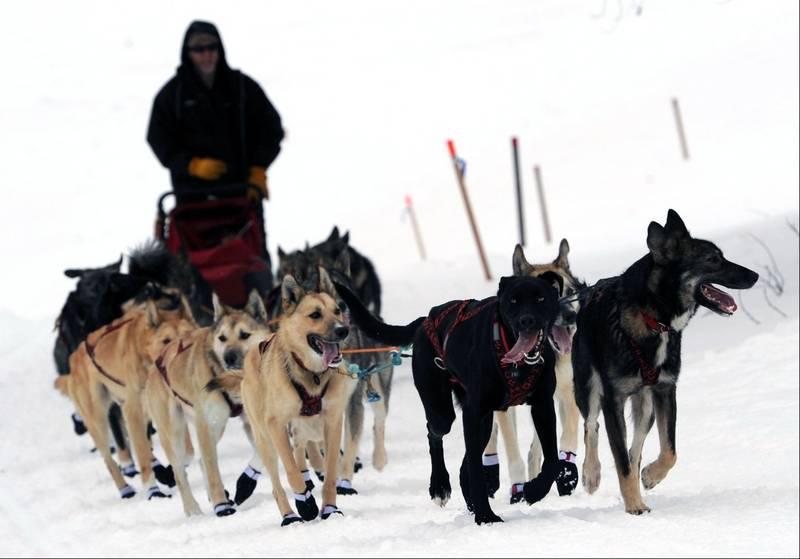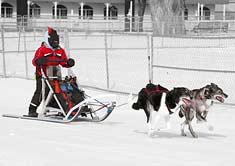The first image is the image on the left, the second image is the image on the right. Given the left and right images, does the statement "Most of the dogs on one sled team are wearing black booties with a white band across the top." hold true? Answer yes or no. Yes. The first image is the image on the left, the second image is the image on the right. Evaluate the accuracy of this statement regarding the images: "Most of the dogs in one of the images are wearing boots.". Is it true? Answer yes or no. Yes. 